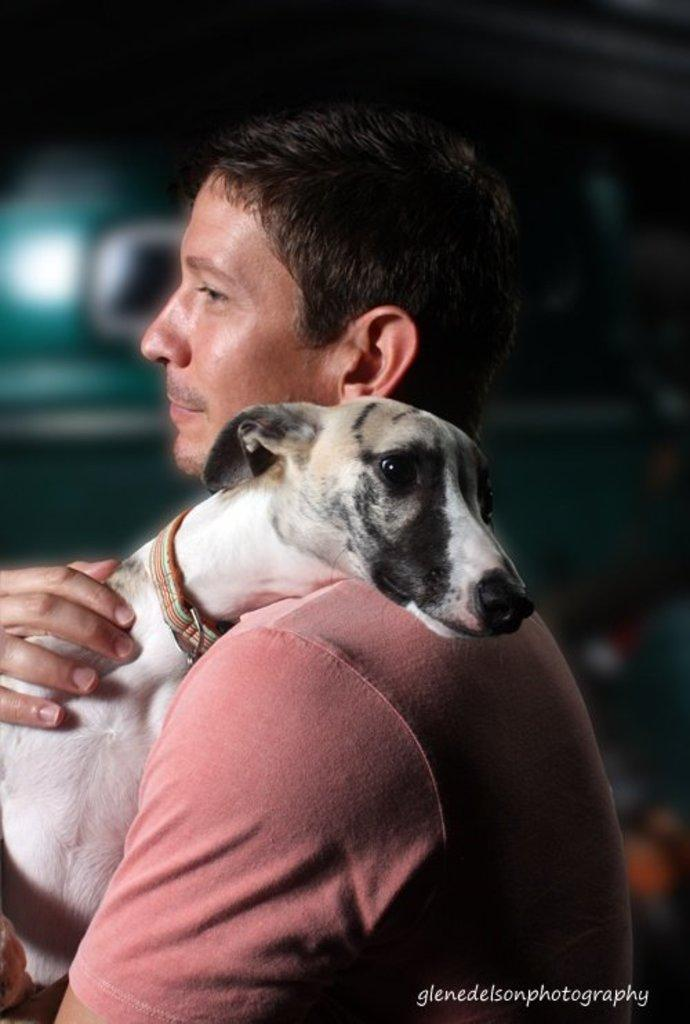Who is the main subject in the image? There is a man in the image. What is the man wearing? The man is wearing a peach-colored shirt. What is the man doing in the image? The man is holding a dog in his arms. Can you describe the dog in the image? The dog has a band around its neck and is white in color. What type of friction is present between the man and the dog in the image? There is no mention of friction in the image, as the man is holding the dog in his arms. Is the man in the image a minister? There is no indication in the image that the man is a minister. 